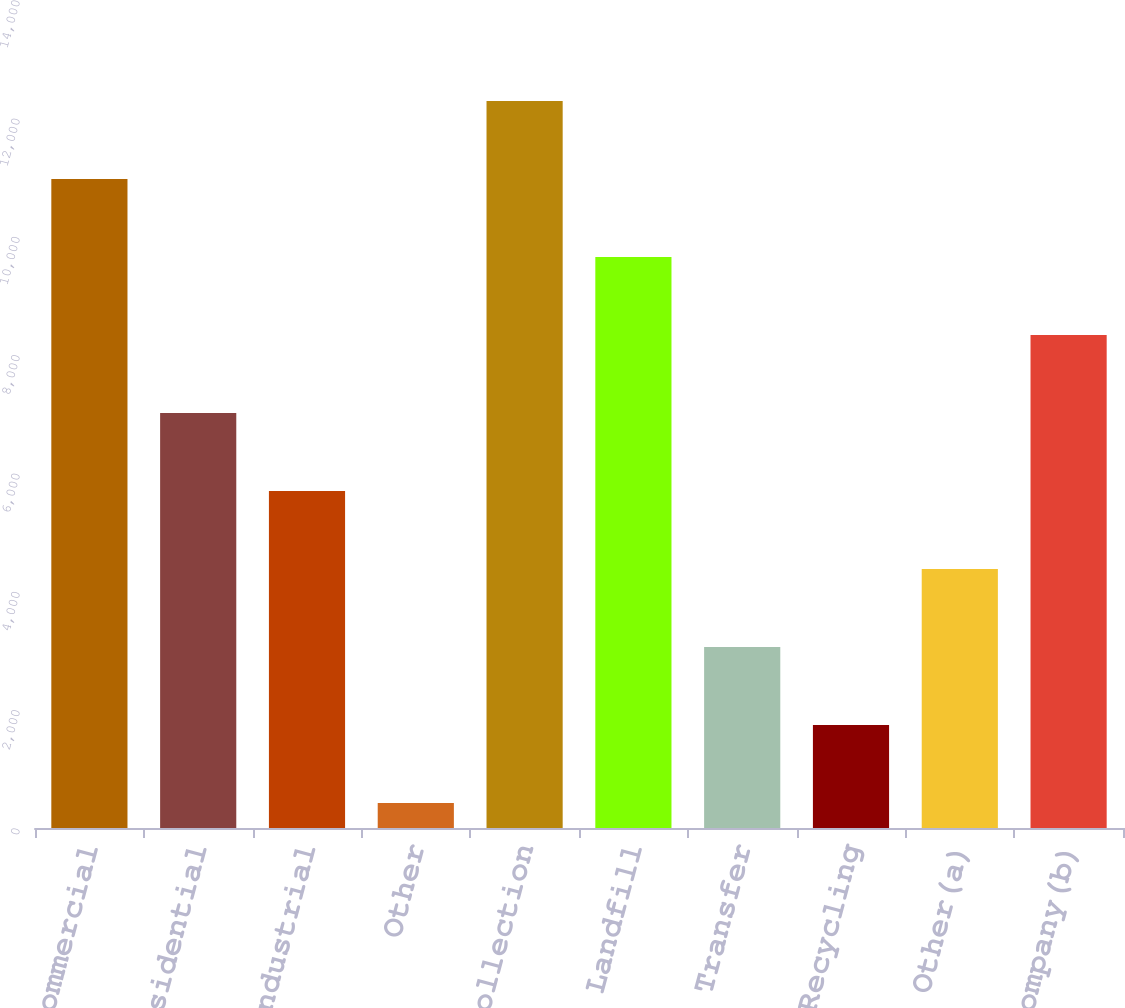Convert chart to OTSL. <chart><loc_0><loc_0><loc_500><loc_500><bar_chart><fcel>Commercial<fcel>Residential<fcel>Industrial<fcel>Other<fcel>Total collection<fcel>Landfill<fcel>Transfer<fcel>Recycling<fcel>Other(a)<fcel>Intercompany(b)<nl><fcel>10971.8<fcel>7016<fcel>5697.4<fcel>423<fcel>12290.4<fcel>9653.2<fcel>3060.2<fcel>1741.6<fcel>4378.8<fcel>8334.6<nl></chart> 